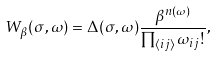Convert formula to latex. <formula><loc_0><loc_0><loc_500><loc_500>W _ { \beta } ( \sigma , \omega ) = \Delta ( \sigma , \omega ) \frac { \beta ^ { n ( \omega ) } } { \prod _ { \langle i j \rangle } \omega _ { i j } ! } ,</formula> 